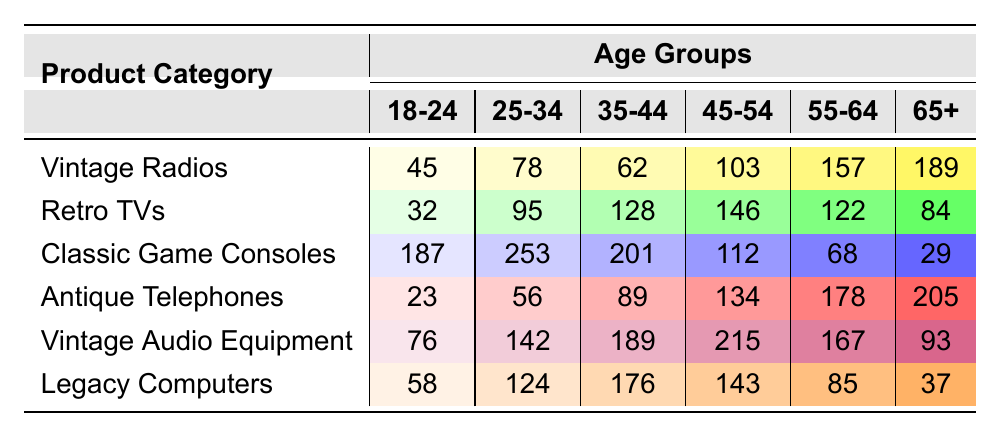What is the total number of Vintage Radios purchased by customers aged 65 and over? Looking at the Vintage Radios row under the 65+ age group, the value is 189.
Answer: 189 Which product category has the highest number of purchases among customers aged 18-24? In the 18-24 age group, the Classic Game Consoles category has the highest value of 187.
Answer: Classic Game Consoles What is the range of purchases for Antique Telephones across all age groups? The highest value for Antique Telephones is 205 (in the 65+ age group) and the lowest is 23 (in the 18-24 age group). The range is 205 - 23 = 182.
Answer: 182 Is the number of Vintage Audio Equipment purchased by customers aged 45-54 greater than that of Retro TVs? For Vintage Audio Equipment, the value for 45-54 age group is 215, while for Retro TVs it is 146, so 215 > 146 is true.
Answer: Yes What is the average number of purchases for Legacy Computers across all age groups? The total for Legacy Computers is 58 + 124 + 176 + 143 + 85 + 37 = 623, and there are 6 age groups. The average is 623 / 6 = approximately 103.83.
Answer: 103.83 Which age group has the lowest purchase for Retro TVs? The lowest number of Retro TV purchases is in the 18-24 age group, where the value is 32.
Answer: 32 Are there more purchases for Vintage Audio Equipment than Antique Telephones in the 55-64 age group? For Vintage Audio Equipment, the value is 167, while for Antique Telephones it is 178. Since 167 < 178, the statement is false.
Answer: No What is the difference in purchases between the highest and lowest age group for Classic Game Consoles? The highest for Classic Game Consoles is 253 (25-34 age group), and the lowest is 29 (65+ age group). The difference is 253 - 29 = 224.
Answer: 224 How many more purchases of Vintage Radios were made by the 55-64 age group compared to the 18-24 age group? For Vintage Radios, the value for 55-64 age group is 157, and for the 18-24 age group it is 45. The difference is 157 - 45 = 112.
Answer: 112 What is the total number of purchases for all product categories by customers aged 35-44? The total for the 35-44 age group is calculated as 62 (Vintage Radios) + 128 (Retro TVs) + 201 (Classic Game Consoles) + 89 (Antique Telephones) + 189 (Vintage Audio Equipment) + 176 (Legacy Computers), totaling 945.
Answer: 945 